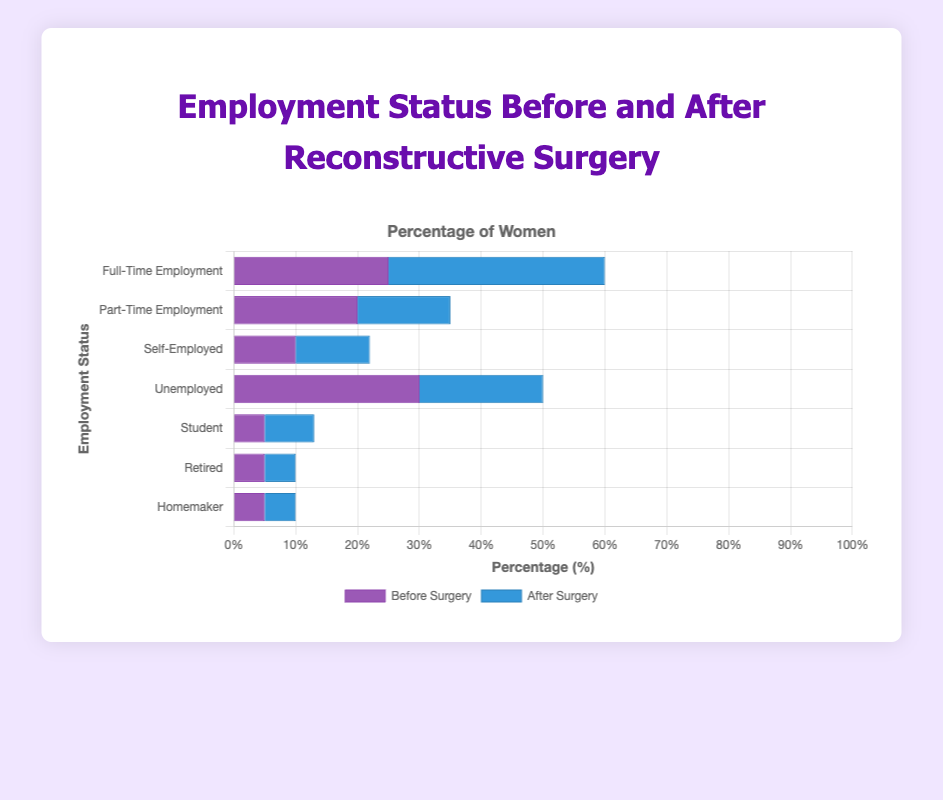Which employment status category showed the largest increase in the percentage of women after the surgery? The 'Full-Time Employment' category increased from 25% before surgery to 35% after surgery, showing the largest increase of 10%.
Answer: Full-Time Employment Which employment status decreased the most after the surgery? The 'Unemployed' category decreased from 30% before surgery to 20% after surgery, showing the largest decrease of 10%.
Answer: Unemployed What is the total percentage of women employed (full-time, part-time, self-employed) before and after surgery? Before surgery, the total is 25% (full-time) + 20% (part-time) + 10% (self-employed) = 55%. After surgery, it is 35% (full-time) + 15% (part-time) + 12% (self-employed) = 62%.
Answer: Before: 55%, After: 62% Did the percentage of women in part-time employment increase or decrease after the surgery? By how much? The percentage of women in part-time employment decreased from 20% to 15%, which is a decrease of 5%.
Answer: Decrease by 5% Among 'Student,' 'Retired,' and 'Homemaker' categories, which one had a change after surgery? Among 'Student' (5% to 8%), 'Retired' (5% to 5%), and 'Homemaker' (5% to 5%), only the 'Student' category had a change, increasing by 3%.
Answer: Student How many categories remained the same in their percentages before and after surgery? The 'Retired' and 'Homemaker' categories both remained the same with 5% before and after surgery, so two categories remained unchanged.
Answer: Two What is the combined percentage of women who were either 'Retired' or 'Homemaker' before surgery? Has this combined value changed after surgery? Before surgery, the combined percentage of 'Retired' and 'Homemaker' is 5% + 5% = 10%. After surgery, it remains the same at 5% + 5% = 10%.
Answer: No change Which two employment status categories have equal percentages after surgery? After surgery, the 'Retired' and 'Homemaker' categories both have equal percentages of 5%.
Answer: Retired and Homemaker By how much did the percentage of 'Self-Employed' women change after surgery? The percentage of 'Self-Employed' women increased from 10% to 12%, which is a change of 2%.
Answer: Increase by 2% Is the average percentage of women in all employment statuses higher before or after surgery? To find the average before surgery: (25 + 20 + 10 + 30 + 5 + 5 + 5) / 7 = 100 / 7 ≈ 14.29%. After surgery: (35 + 15 + 12 + 20 + 8 + 5 + 5) / 7 = 100 / 7 ≈ 14.29%. The average percentage is the same before and after surgery at approximately 14.29%.
Answer: Same 